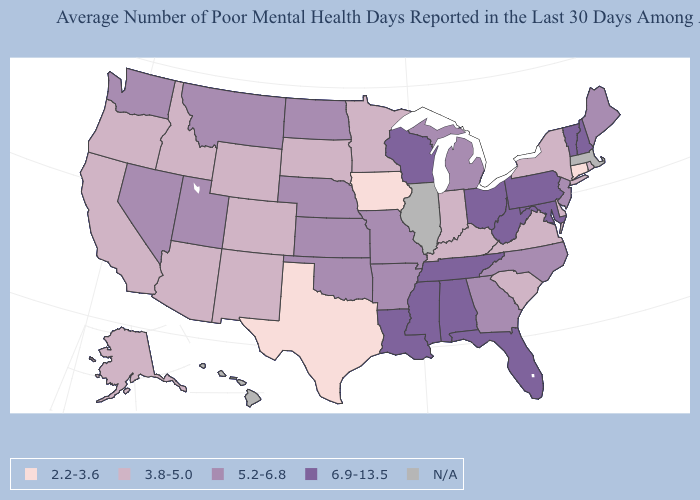Does Texas have the lowest value in the USA?
Short answer required. Yes. Name the states that have a value in the range N/A?
Write a very short answer. Hawaii, Illinois, Massachusetts. How many symbols are there in the legend?
Answer briefly. 5. What is the value of Iowa?
Concise answer only. 2.2-3.6. What is the value of Illinois?
Concise answer only. N/A. What is the value of Rhode Island?
Concise answer only. 3.8-5.0. What is the lowest value in states that border Kentucky?
Be succinct. 3.8-5.0. Does West Virginia have the highest value in the South?
Write a very short answer. Yes. Name the states that have a value in the range 3.8-5.0?
Short answer required. Alaska, Arizona, California, Colorado, Delaware, Idaho, Indiana, Kentucky, Minnesota, New Mexico, New York, Oregon, Rhode Island, South Carolina, South Dakota, Virginia, Wyoming. Name the states that have a value in the range 2.2-3.6?
Short answer required. Connecticut, Iowa, Texas. What is the lowest value in states that border New Hampshire?
Be succinct. 5.2-6.8. Name the states that have a value in the range 5.2-6.8?
Be succinct. Arkansas, Georgia, Kansas, Maine, Michigan, Missouri, Montana, Nebraska, Nevada, New Jersey, North Carolina, North Dakota, Oklahoma, Utah, Washington. Name the states that have a value in the range 2.2-3.6?
Keep it brief. Connecticut, Iowa, Texas. Does the first symbol in the legend represent the smallest category?
Be succinct. Yes. 